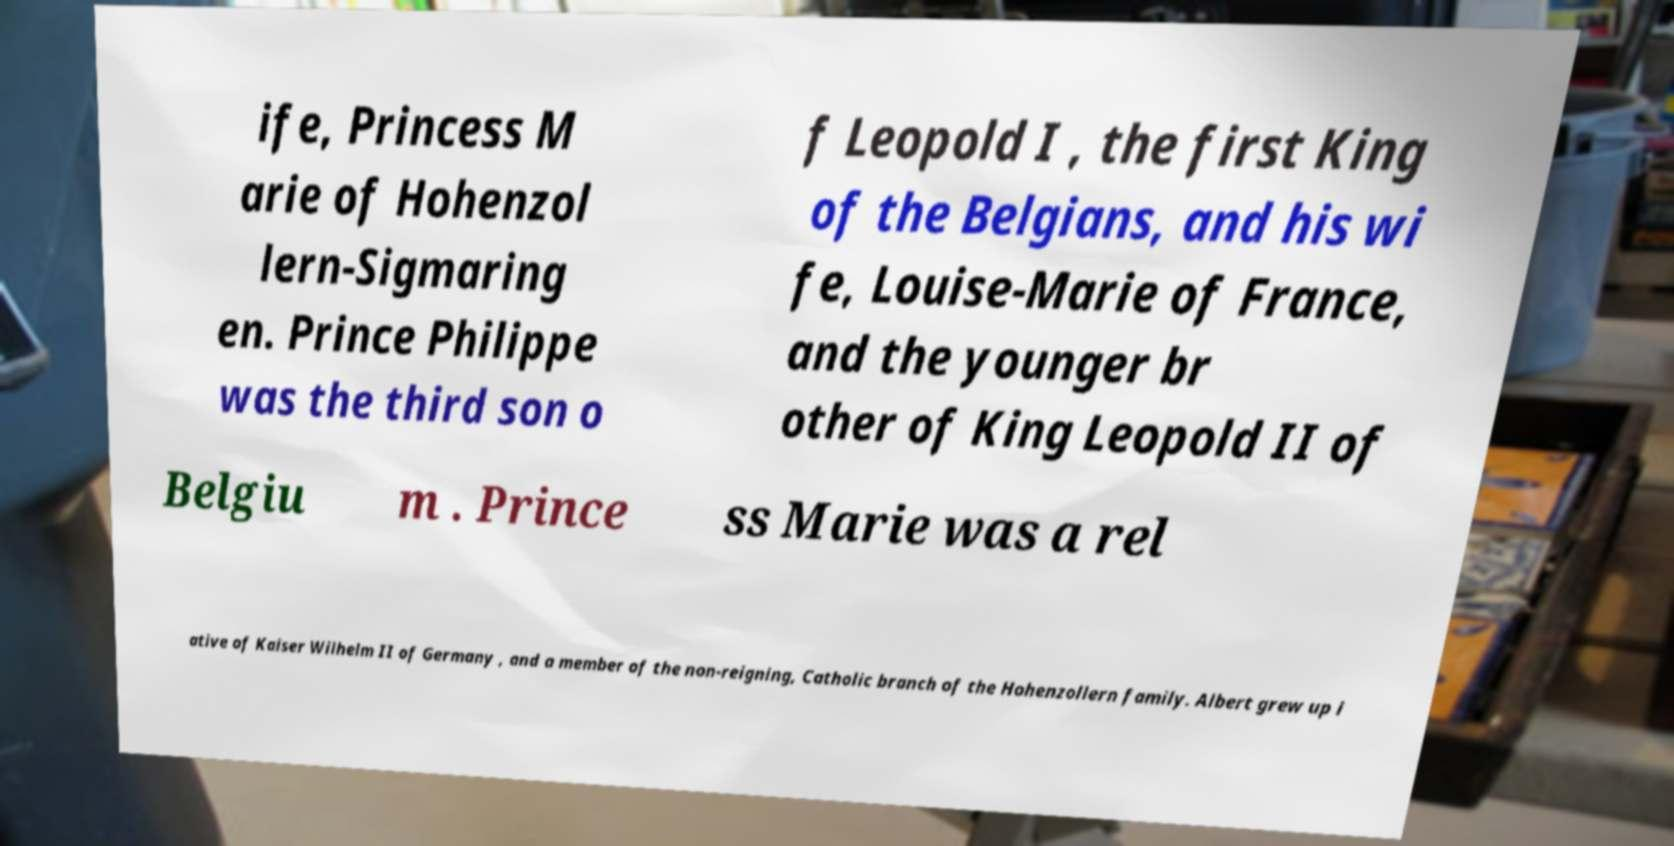Please identify and transcribe the text found in this image. ife, Princess M arie of Hohenzol lern-Sigmaring en. Prince Philippe was the third son o f Leopold I , the first King of the Belgians, and his wi fe, Louise-Marie of France, and the younger br other of King Leopold II of Belgiu m . Prince ss Marie was a rel ative of Kaiser Wilhelm II of Germany , and a member of the non-reigning, Catholic branch of the Hohenzollern family. Albert grew up i 